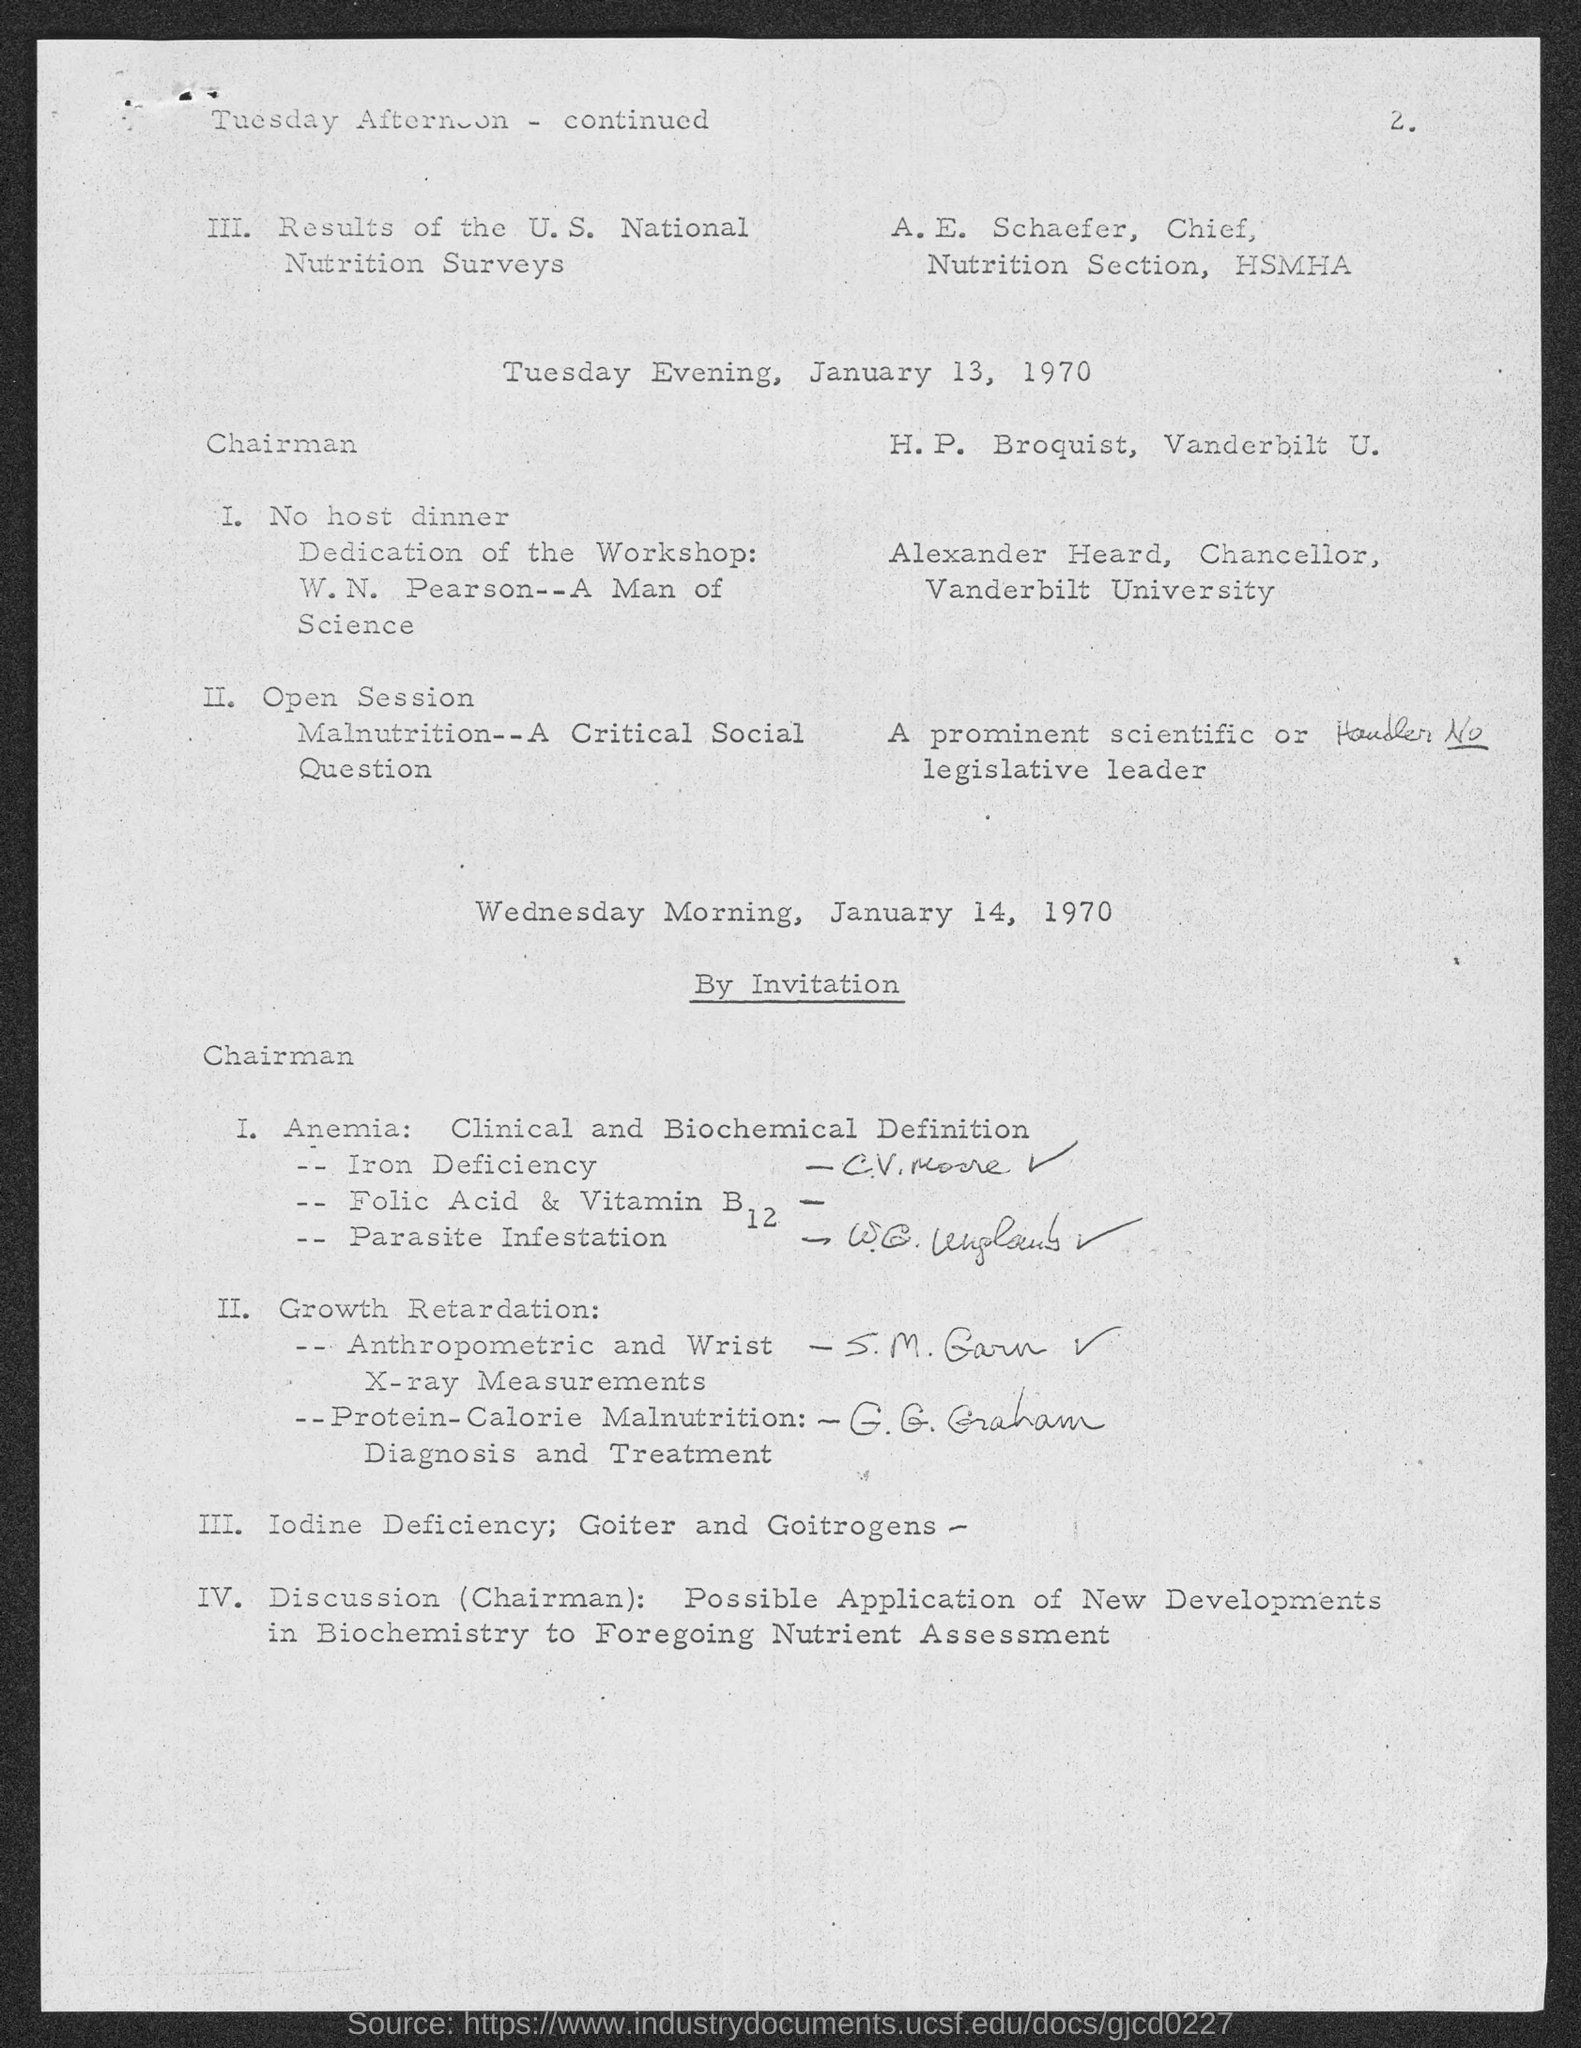Point out several critical features in this image. Alexander Heard is the chancellor of Vanderbilt University. The person in charge of the nutrition section at HSMHA is E. Schaefer. 